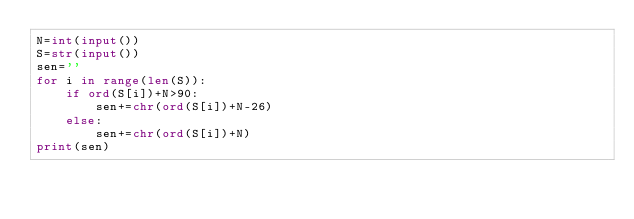<code> <loc_0><loc_0><loc_500><loc_500><_Python_>N=int(input())
S=str(input())
sen=''
for i in range(len(S)):
    if ord(S[i])+N>90:
        sen+=chr(ord(S[i])+N-26)
    else:
        sen+=chr(ord(S[i])+N)
print(sen)</code> 